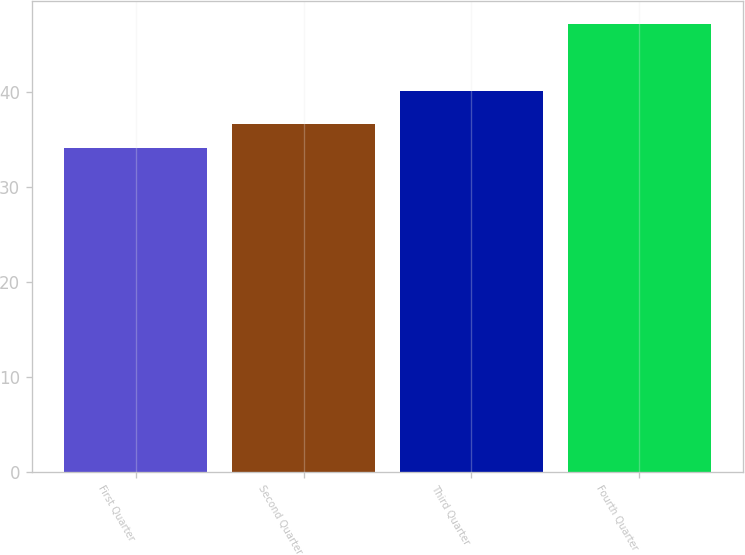<chart> <loc_0><loc_0><loc_500><loc_500><bar_chart><fcel>First Quarter<fcel>Second Quarter<fcel>Third Quarter<fcel>Fourth Quarter<nl><fcel>34.06<fcel>36.63<fcel>40.11<fcel>47.16<nl></chart> 